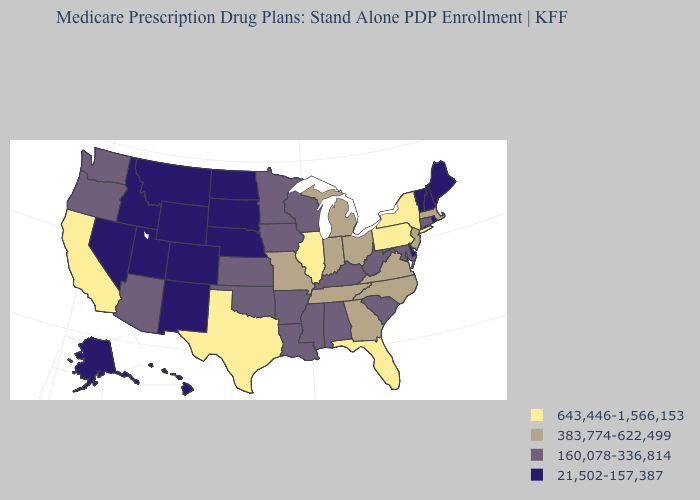What is the value of Nebraska?
Answer briefly. 21,502-157,387. Among the states that border Mississippi , which have the lowest value?
Give a very brief answer. Alabama, Arkansas, Louisiana. Name the states that have a value in the range 383,774-622,499?
Short answer required. Georgia, Indiana, Massachusetts, Michigan, Missouri, North Carolina, New Jersey, Ohio, Tennessee, Virginia. What is the value of New York?
Concise answer only. 643,446-1,566,153. Which states have the highest value in the USA?
Keep it brief. California, Florida, Illinois, New York, Pennsylvania, Texas. Among the states that border California , which have the highest value?
Short answer required. Arizona, Oregon. Which states hav the highest value in the South?
Keep it brief. Florida, Texas. Name the states that have a value in the range 383,774-622,499?
Answer briefly. Georgia, Indiana, Massachusetts, Michigan, Missouri, North Carolina, New Jersey, Ohio, Tennessee, Virginia. Name the states that have a value in the range 383,774-622,499?
Quick response, please. Georgia, Indiana, Massachusetts, Michigan, Missouri, North Carolina, New Jersey, Ohio, Tennessee, Virginia. What is the lowest value in the MidWest?
Give a very brief answer. 21,502-157,387. Among the states that border Delaware , which have the highest value?
Answer briefly. Pennsylvania. What is the highest value in the MidWest ?
Quick response, please. 643,446-1,566,153. What is the highest value in the USA?
Be succinct. 643,446-1,566,153. 